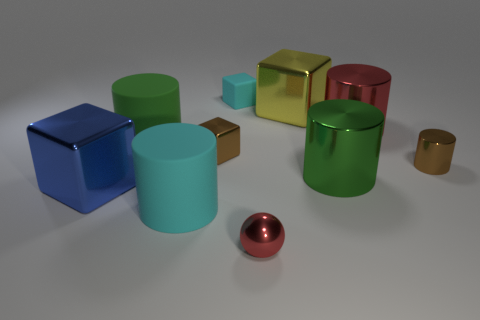What shape is the brown shiny object that is to the right of the big green thing in front of the brown thing behind the brown cylinder?
Ensure brevity in your answer.  Cylinder. How many cylinders are either tiny brown metallic objects or matte objects?
Keep it short and to the point. 3. There is a tiny brown thing that is on the right side of the yellow metallic object; are there any brown objects that are behind it?
Your response must be concise. Yes. Is there anything else that has the same material as the small red ball?
Your answer should be very brief. Yes. Do the green metal thing and the red metallic object left of the big yellow block have the same shape?
Offer a terse response. No. What number of other things are there of the same size as the brown metallic cylinder?
Make the answer very short. 3. What number of red objects are either big things or large metal objects?
Provide a short and direct response. 1. What number of big objects are behind the green metal object and right of the tiny sphere?
Give a very brief answer. 2. There is a green object on the right side of the cylinder in front of the large shiny block that is to the left of the large yellow cube; what is it made of?
Make the answer very short. Metal. What number of large blue blocks are the same material as the yellow object?
Your answer should be compact. 1. 